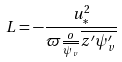Convert formula to latex. <formula><loc_0><loc_0><loc_500><loc_500>L = - \frac { u _ { * } ^ { 2 } } { \varpi \frac { o } { \overline { \psi _ { v } } } \overline { z ^ { \prime } \psi _ { v } ^ { \prime } } }</formula> 